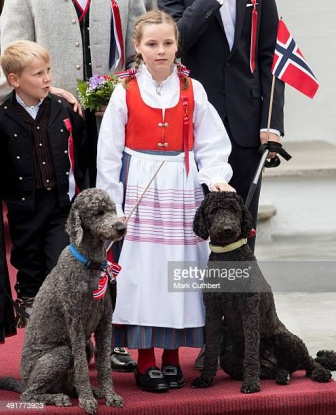What can you tell me about the significance of the traditional Norwegian attire the girl is wearing? The traditional Norwegian attire worn by the girl is known as a 'bunad.' This traditional costume is often worn during important cultural events, national holidays such as Constitution Day on May 17th, weddings, and other special occasions. Each region in Norway has its own specific bunad design, characterized by distinct patterns, colors, and embroidery. The white dress with stripes and the red vest seen here likely represent a particular region's bunad. Wearing such attire is a way to honor and celebrate Norwegian heritage, culture, and identity. 